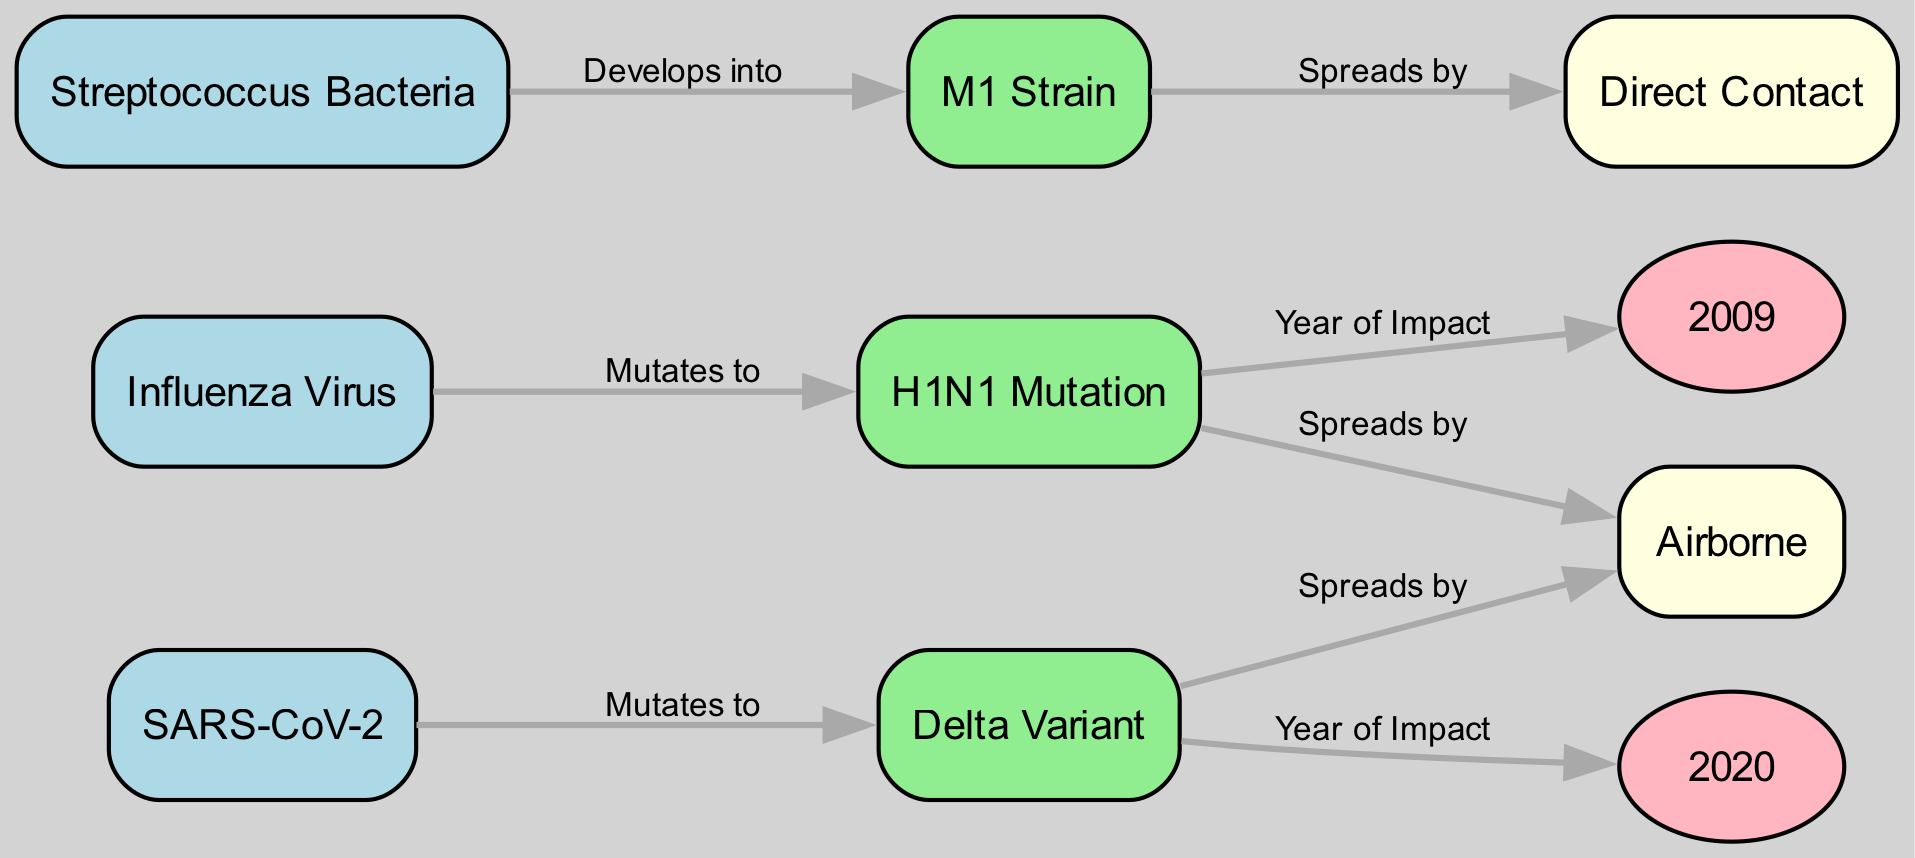What pathogens are shown in the diagram? The diagram includes three pathogens: Influenza Virus, Streptococcus Bacteria, and SARS-CoV-2. They are displayed as nodes in the diagram.
Answer: Influenza Virus, Streptococcus Bacteria, SARS-CoV-2 How many mutations are depicted in the diagram? There are three mutations represented in the diagram: H1N1 Mutation, M1 Strain, and Delta Variant. Each mutation is connected to its corresponding pathogen.
Answer: 3 Which pathogen mutates into the H1N1 strain? The diagram indicates that the Influenza Virus mutates into the H1N1 Mutation. This is shown as a directed edge from the Influenza Virus node to the H1N1 Mutation node.
Answer: Influenza Virus What year is associated with the H1N1 pandemic? The diagram connects the H1N1 Mutation to the year 2009, indicating that this is the significant year for the impact of the H1N1 pandemic.
Answer: 2009 Which transmission method is associated with the Delta variant? The Delta Variant transmits mainly through the airborne transmission method, which is presented in the diagram as a directed edge from the Delta Variant node.
Answer: Airborne What is the relationship between the Streptococcus bacteria and the M1 strain? The relationship is that Streptococcus bacteria evolves into the M1 Strain, as indicated by an edge labeled "Develops into" connecting these two nodes in the diagram.
Answer: Develops into Which transmission method is linked to the H1N1 Mutation? The H1N1 Mutation spreads by airborne transmission, indicated by a directed edge from the H1N1 Mutation node to the transmission method node.
Answer: Airborne How does the M1 strain primarily spread? The M1 strain primarily spreads through direct contact, as shown by the edge leading from the M1 Strain node to the transmission method node labeled "Direct Contact."
Answer: Direct Contact What is the main transmission route for both the Delta variant and H1N1 Mutation? Both the Delta variant and H1N1 Mutation share the main transmission route of airborne transmission, reflecting a common method of spread for these pathogens.
Answer: Airborne 